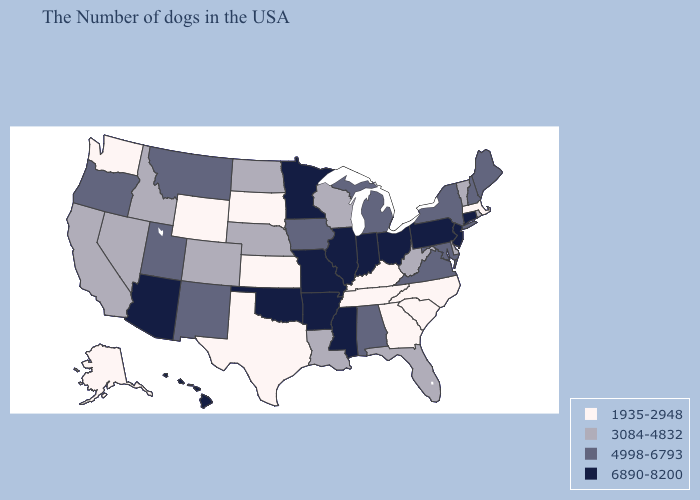What is the highest value in the Northeast ?
Give a very brief answer. 6890-8200. What is the highest value in the South ?
Write a very short answer. 6890-8200. Which states have the lowest value in the USA?
Answer briefly. Massachusetts, North Carolina, South Carolina, Georgia, Kentucky, Tennessee, Kansas, Texas, South Dakota, Wyoming, Washington, Alaska. Does Virginia have a higher value than Missouri?
Short answer required. No. Name the states that have a value in the range 3084-4832?
Concise answer only. Rhode Island, Vermont, Delaware, West Virginia, Florida, Wisconsin, Louisiana, Nebraska, North Dakota, Colorado, Idaho, Nevada, California. Among the states that border Massachusetts , which have the highest value?
Short answer required. Connecticut. Name the states that have a value in the range 4998-6793?
Give a very brief answer. Maine, New Hampshire, New York, Maryland, Virginia, Michigan, Alabama, Iowa, New Mexico, Utah, Montana, Oregon. Among the states that border Kentucky , which have the highest value?
Be succinct. Ohio, Indiana, Illinois, Missouri. Does Wyoming have the same value as Tennessee?
Concise answer only. Yes. What is the value of South Dakota?
Short answer required. 1935-2948. Name the states that have a value in the range 3084-4832?
Be succinct. Rhode Island, Vermont, Delaware, West Virginia, Florida, Wisconsin, Louisiana, Nebraska, North Dakota, Colorado, Idaho, Nevada, California. What is the highest value in the USA?
Give a very brief answer. 6890-8200. What is the highest value in the MidWest ?
Quick response, please. 6890-8200. What is the lowest value in states that border South Dakota?
Quick response, please. 1935-2948. What is the value of Arizona?
Keep it brief. 6890-8200. 